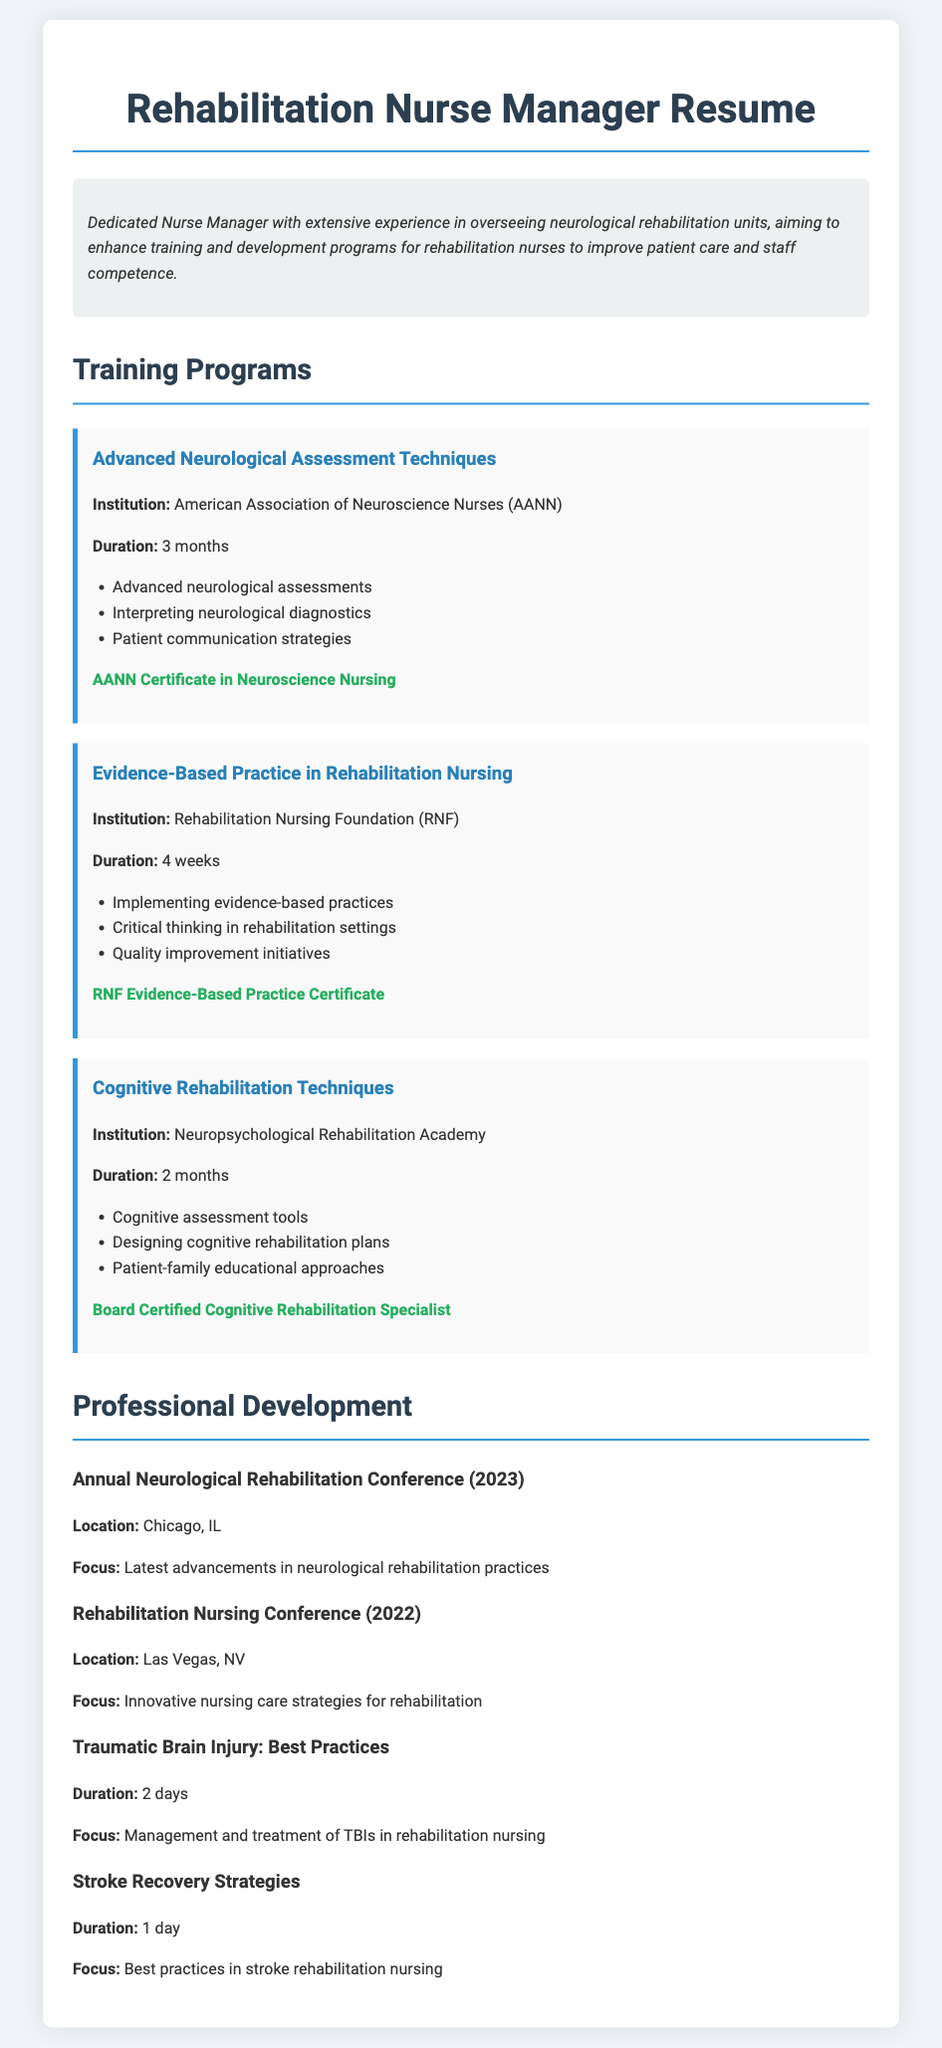What is the name of the first training program? The first training program listed is titled "Advanced Neurological Assessment Techniques."
Answer: Advanced Neurological Assessment Techniques What is the duration of the "Evidence-Based Practice in Rehabilitation Nursing" program? The duration of this program is specified in the document.
Answer: 4 weeks Which institution offers the "Cognitive Rehabilitation Techniques" program? The document states that this program is offered by the Neuropsychological Rehabilitation Academy.
Answer: Neuropsychological Rehabilitation Academy What certification is awarded after completing the "Advanced Neurological Assessment Techniques" program? The document mentions the specific certification received upon completion of this program.
Answer: AANN Certificate in Neuroscience Nursing What was the focus of the Annual Neurological Rehabilitation Conference (2023)? The focus of the conference is detailed in the document.
Answer: Latest advancements in neurological rehabilitation practices Which city hosted the Rehabilitation Nursing Conference in 2022? The document provides the location of this conference.
Answer: Las Vegas, NV How long is the "Traumatic Brain Injury: Best Practices" workshop? The document indicates the duration of this workshop.
Answer: 2 days What is one of the topics covered in the "Cognitive Rehabilitation Techniques" program? The document lists various topics covered in this program.
Answer: Cognitive assessment tools 